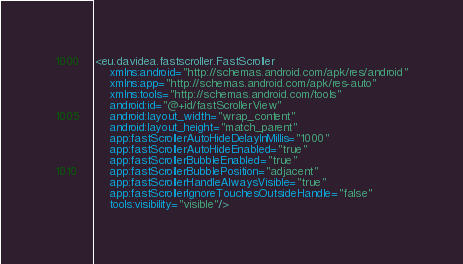<code> <loc_0><loc_0><loc_500><loc_500><_XML_><eu.davidea.fastscroller.FastScroller
    xmlns:android="http://schemas.android.com/apk/res/android"
    xmlns:app="http://schemas.android.com/apk/res-auto"
    xmlns:tools="http://schemas.android.com/tools"
    android:id="@+id/fastScrollerView"
    android:layout_width="wrap_content"
    android:layout_height="match_parent"
    app:fastScrollerAutoHideDelayInMillis="1000"
    app:fastScrollerAutoHideEnabled="true"
    app:fastScrollerBubbleEnabled="true"
    app:fastScrollerBubblePosition="adjacent"
    app:fastScrollerHandleAlwaysVisible="true"
    app:fastScrollerIgnoreTouchesOutsideHandle="false"
    tools:visibility="visible"/></code> 